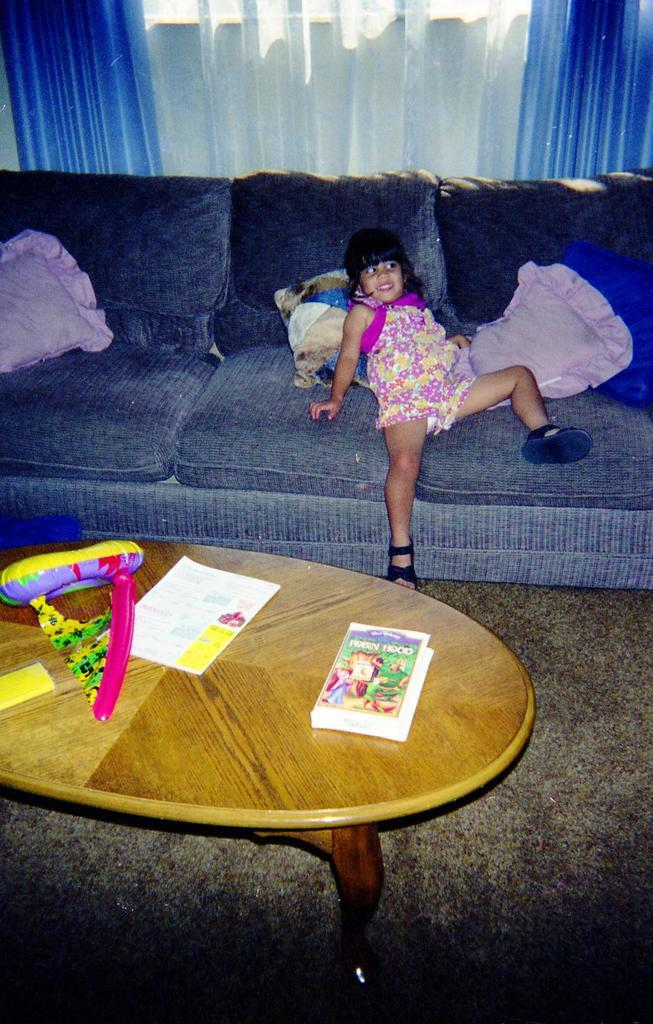What is the girl doing in the image? The girl is sitting on a couch in the image. What is in front of the girl? There is a table in front of the girl. What items can be seen on the table? Books and balloons are present on the table. What can be seen behind the girl? There are curtains visible behind the girl. What type of weather can be seen through the window in the image? There is no window visible in the image, so it is not possible to determine the weather. 